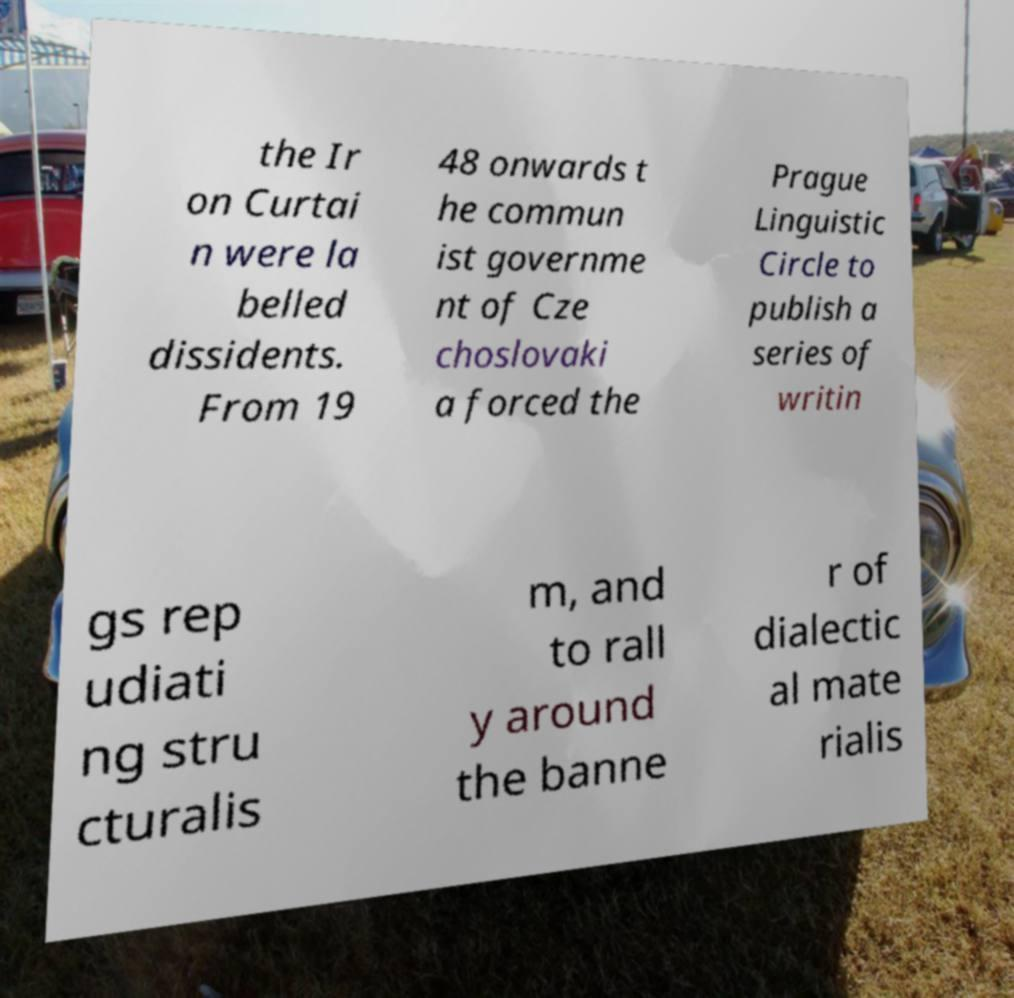Please read and relay the text visible in this image. What does it say? the Ir on Curtai n were la belled dissidents. From 19 48 onwards t he commun ist governme nt of Cze choslovaki a forced the Prague Linguistic Circle to publish a series of writin gs rep udiati ng stru cturalis m, and to rall y around the banne r of dialectic al mate rialis 